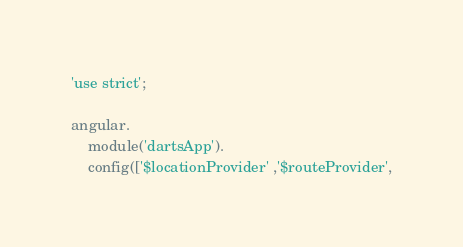Convert code to text. <code><loc_0><loc_0><loc_500><loc_500><_JavaScript_>'use strict';

angular.
    module('dartsApp').
    config(['$locationProvider' ,'$routeProvider',</code> 